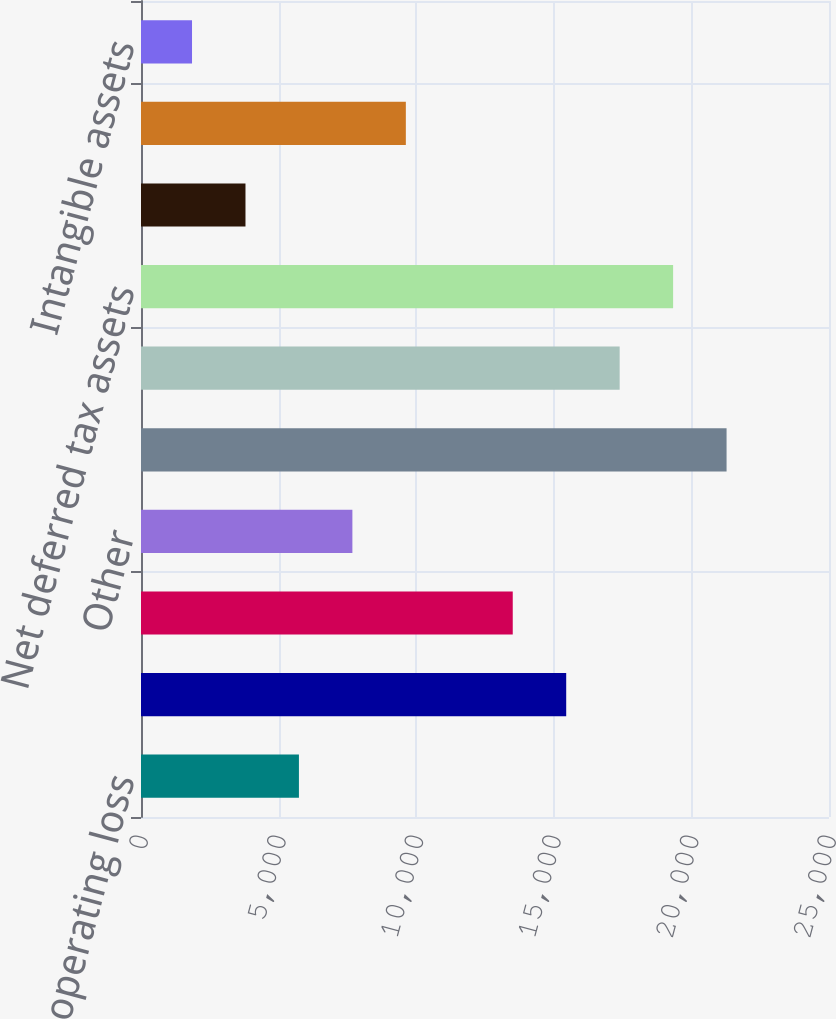Convert chart to OTSL. <chart><loc_0><loc_0><loc_500><loc_500><bar_chart><fcel>US net operating loss<fcel>Capital loss carryforwards<fcel>Stock compensation expense<fcel>Other<fcel>Total deferred tax assets<fcel>Valuation allowance<fcel>Net deferred tax assets<fcel>Depreciation and amortization<fcel>Capitalized software<fcel>Intangible assets<nl><fcel>5738.8<fcel>15450.8<fcel>13508.4<fcel>7681.2<fcel>21278<fcel>17393.2<fcel>19335.6<fcel>3796.4<fcel>9623.6<fcel>1854<nl></chart> 